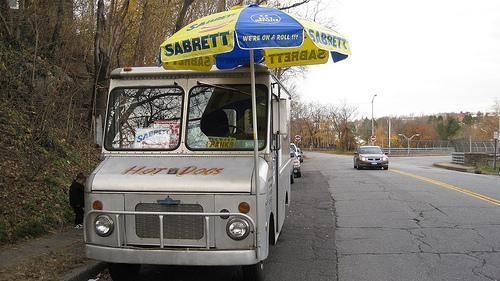How many umbrellas are visible in this photo?
Give a very brief answer. 1. How many red vehicles are in the image?
Give a very brief answer. 0. 